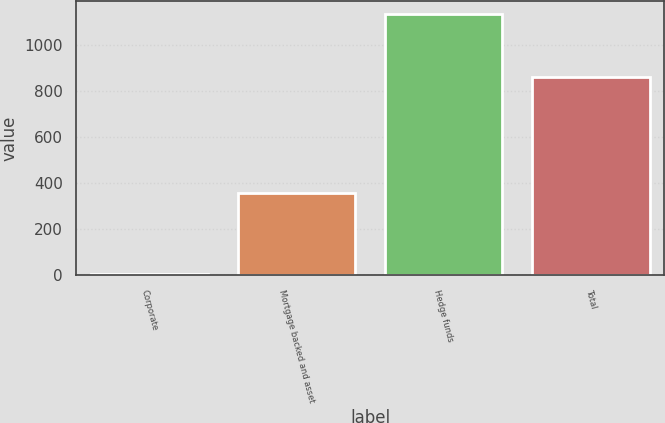Convert chart to OTSL. <chart><loc_0><loc_0><loc_500><loc_500><bar_chart><fcel>Corporate<fcel>Mortgage backed and asset<fcel>Hedge funds<fcel>Total<nl><fcel>7<fcel>358<fcel>1134<fcel>861<nl></chart> 